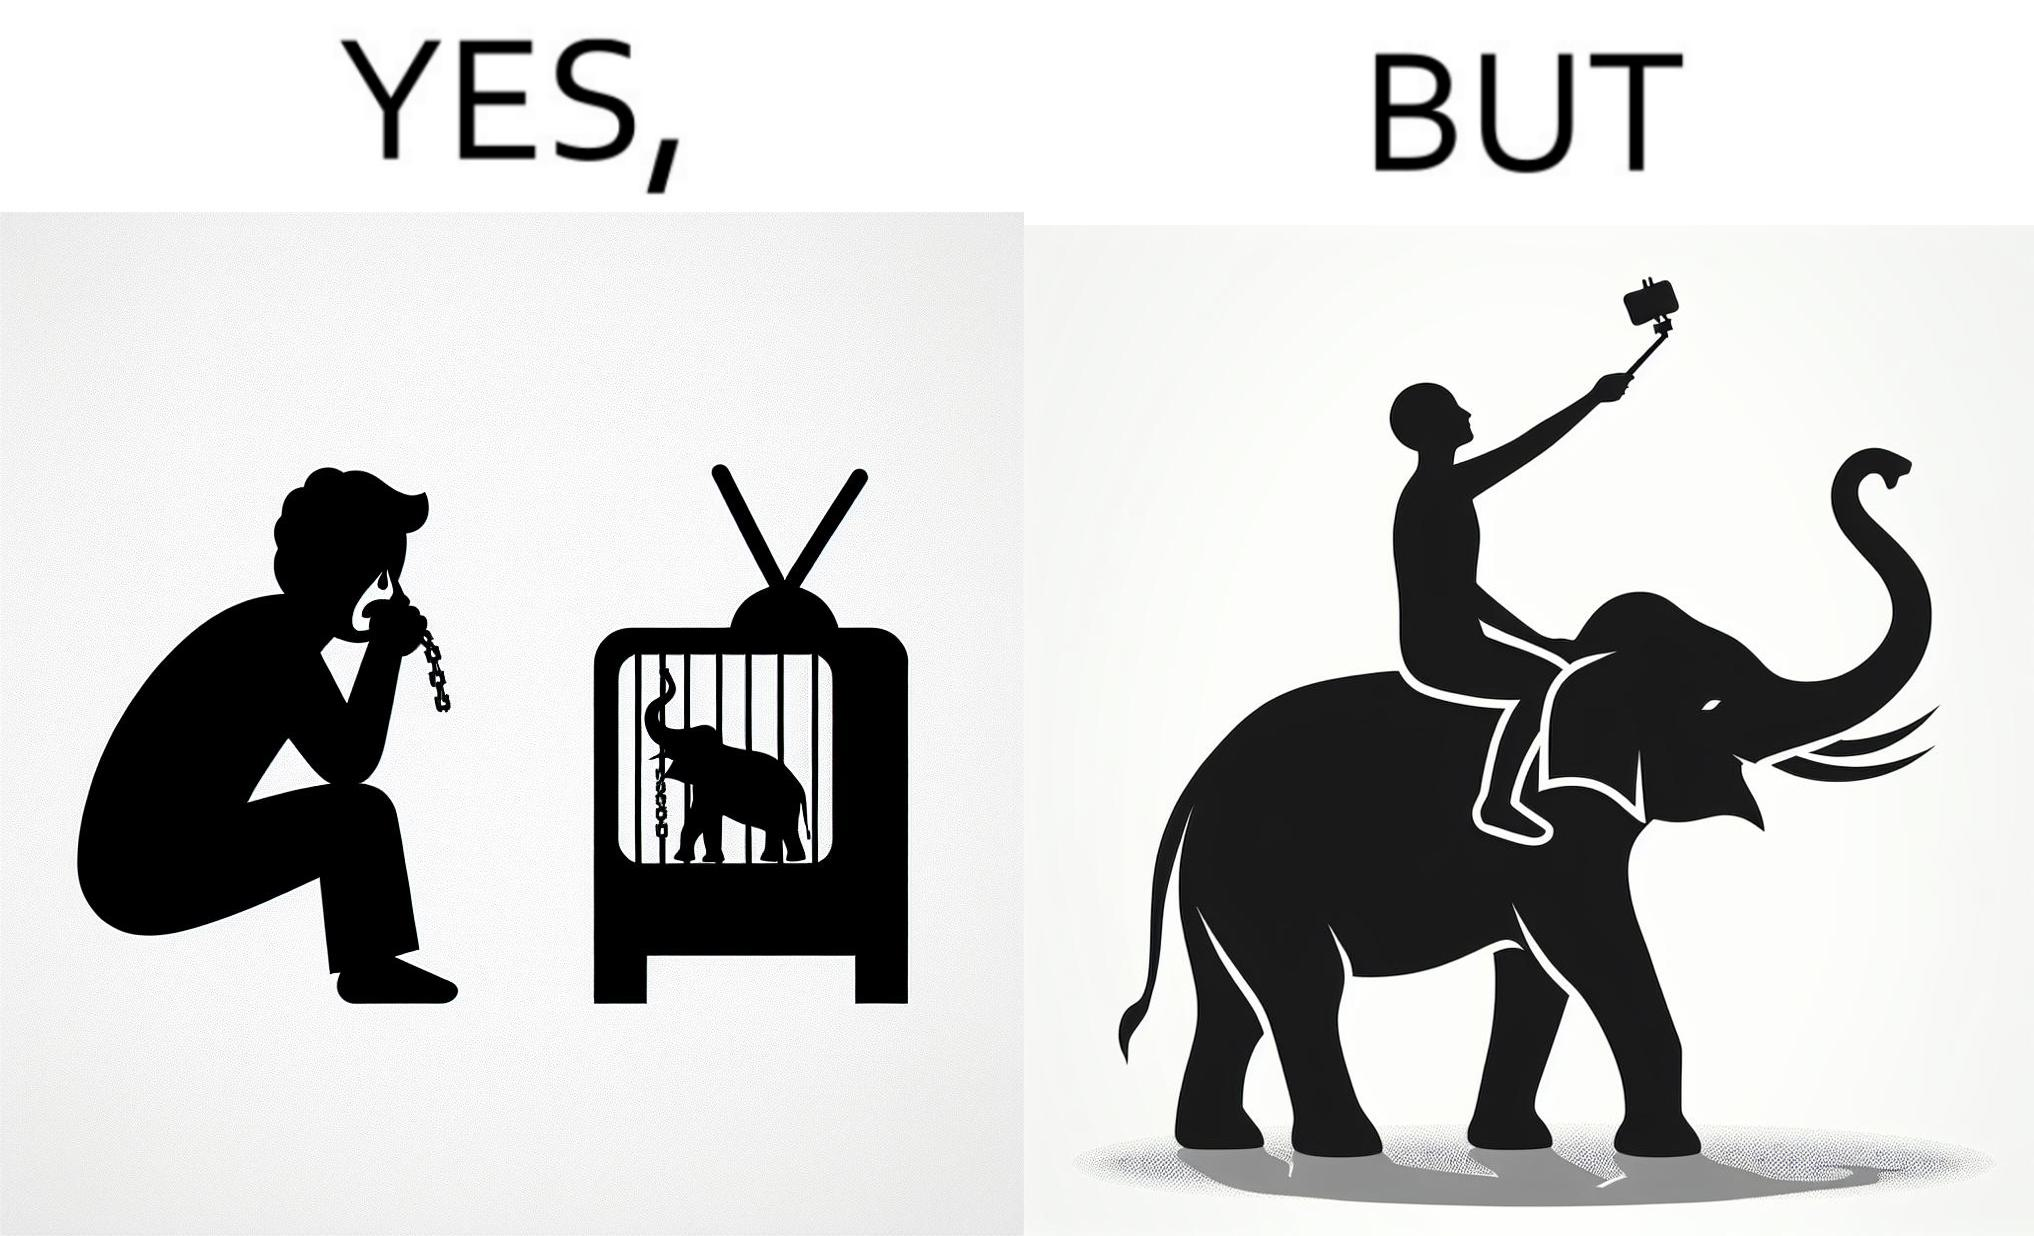Describe the content of this image. The image is ironic, because the people who get sentimental over imprisoned animal while watching TV shows often feel okay when using animals for labor 